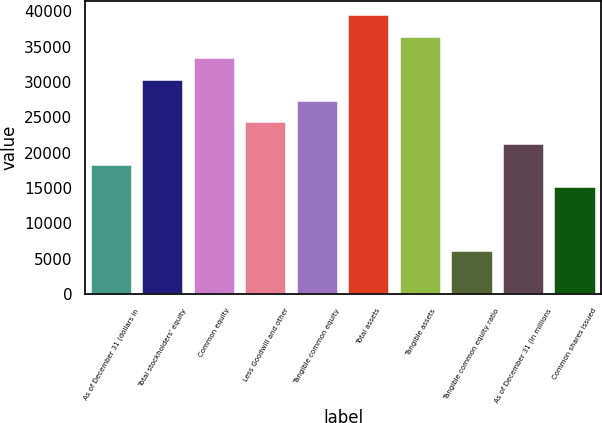<chart> <loc_0><loc_0><loc_500><loc_500><bar_chart><fcel>As of December 31 (dollars in<fcel>Total stockholders' equity<fcel>Common equity<fcel>Less Goodwill and other<fcel>Tangible common equity<fcel>Total assets<fcel>Tangible assets<fcel>Tangible common equity ratio<fcel>As of December 31 (in millions<fcel>Common shares issued<nl><fcel>18210.9<fcel>30346<fcel>33379.7<fcel>24278.4<fcel>27312.2<fcel>39447.2<fcel>36413.5<fcel>6075.88<fcel>21244.7<fcel>15177.2<nl></chart> 